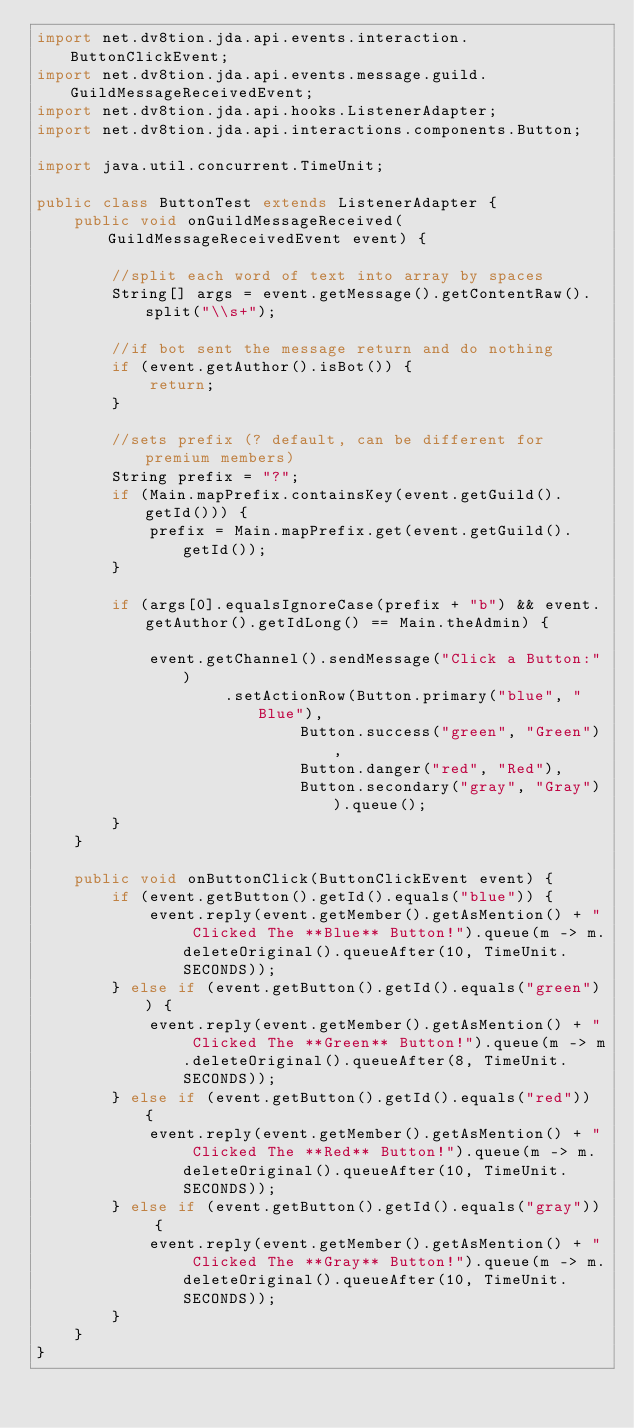<code> <loc_0><loc_0><loc_500><loc_500><_Java_>import net.dv8tion.jda.api.events.interaction.ButtonClickEvent;
import net.dv8tion.jda.api.events.message.guild.GuildMessageReceivedEvent;
import net.dv8tion.jda.api.hooks.ListenerAdapter;
import net.dv8tion.jda.api.interactions.components.Button;

import java.util.concurrent.TimeUnit;

public class ButtonTest extends ListenerAdapter {
    public void onGuildMessageReceived(GuildMessageReceivedEvent event) {

        //split each word of text into array by spaces
        String[] args = event.getMessage().getContentRaw().split("\\s+");

        //if bot sent the message return and do nothing
        if (event.getAuthor().isBot()) {
            return;
        }

        //sets prefix (? default, can be different for premium members)
        String prefix = "?";
        if (Main.mapPrefix.containsKey(event.getGuild().getId())) {
            prefix = Main.mapPrefix.get(event.getGuild().getId());
        }

        if (args[0].equalsIgnoreCase(prefix + "b") && event.getAuthor().getIdLong() == Main.theAdmin) {

            event.getChannel().sendMessage("Click a Button:")
                    .setActionRow(Button.primary("blue", "Blue"),
                            Button.success("green", "Green"),
                            Button.danger("red", "Red"),
                            Button.secondary("gray", "Gray")).queue();
        }
    }

    public void onButtonClick(ButtonClickEvent event) {
        if (event.getButton().getId().equals("blue")) {
            event.reply(event.getMember().getAsMention() + " Clicked The **Blue** Button!").queue(m -> m.deleteOriginal().queueAfter(10, TimeUnit.SECONDS));
        } else if (event.getButton().getId().equals("green")) {
            event.reply(event.getMember().getAsMention() + " Clicked The **Green** Button!").queue(m -> m.deleteOriginal().queueAfter(8, TimeUnit.SECONDS));
        } else if (event.getButton().getId().equals("red")) {
            event.reply(event.getMember().getAsMention() + " Clicked The **Red** Button!").queue(m -> m.deleteOriginal().queueAfter(10, TimeUnit.SECONDS));
        } else if (event.getButton().getId().equals("gray")) {
            event.reply(event.getMember().getAsMention() + " Clicked The **Gray** Button!").queue(m -> m.deleteOriginal().queueAfter(10, TimeUnit.SECONDS));
        }
    }
}
</code> 